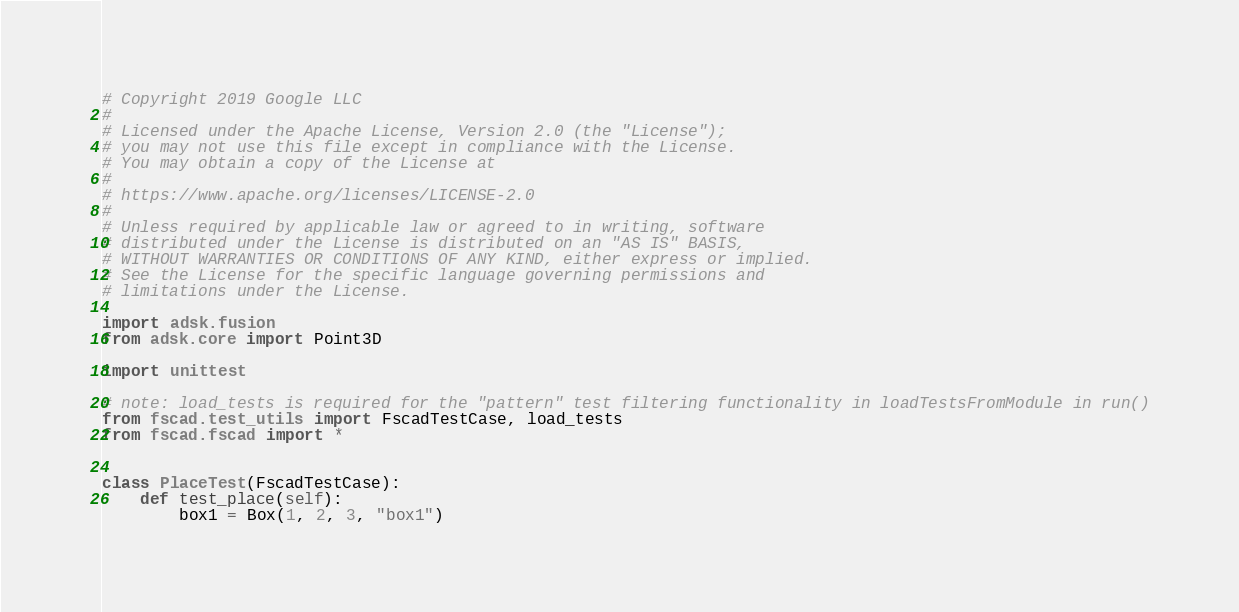Convert code to text. <code><loc_0><loc_0><loc_500><loc_500><_Python_># Copyright 2019 Google LLC
#
# Licensed under the Apache License, Version 2.0 (the "License");
# you may not use this file except in compliance with the License.
# You may obtain a copy of the License at
#
# https://www.apache.org/licenses/LICENSE-2.0
#
# Unless required by applicable law or agreed to in writing, software
# distributed under the License is distributed on an "AS IS" BASIS,
# WITHOUT WARRANTIES OR CONDITIONS OF ANY KIND, either express or implied.
# See the License for the specific language governing permissions and
# limitations under the License.

import adsk.fusion
from adsk.core import Point3D

import unittest

# note: load_tests is required for the "pattern" test filtering functionality in loadTestsFromModule in run()
from fscad.test_utils import FscadTestCase, load_tests
from fscad.fscad import *


class PlaceTest(FscadTestCase):
    def test_place(self):
        box1 = Box(1, 2, 3, "box1")</code> 